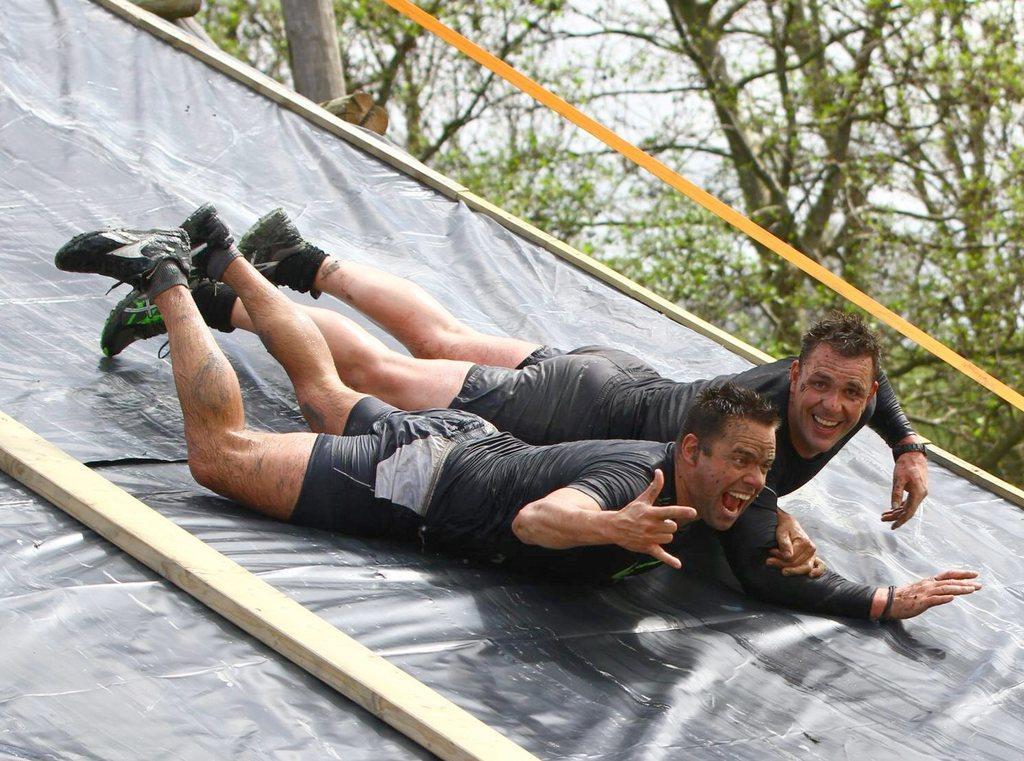Can you describe this image briefly? In this image there are two men who are sliding on the slide. In the background there are trees. Beside the slide there is a yellow colour ribbon. On the slide there is black colour mat and a wooden stick on it. 